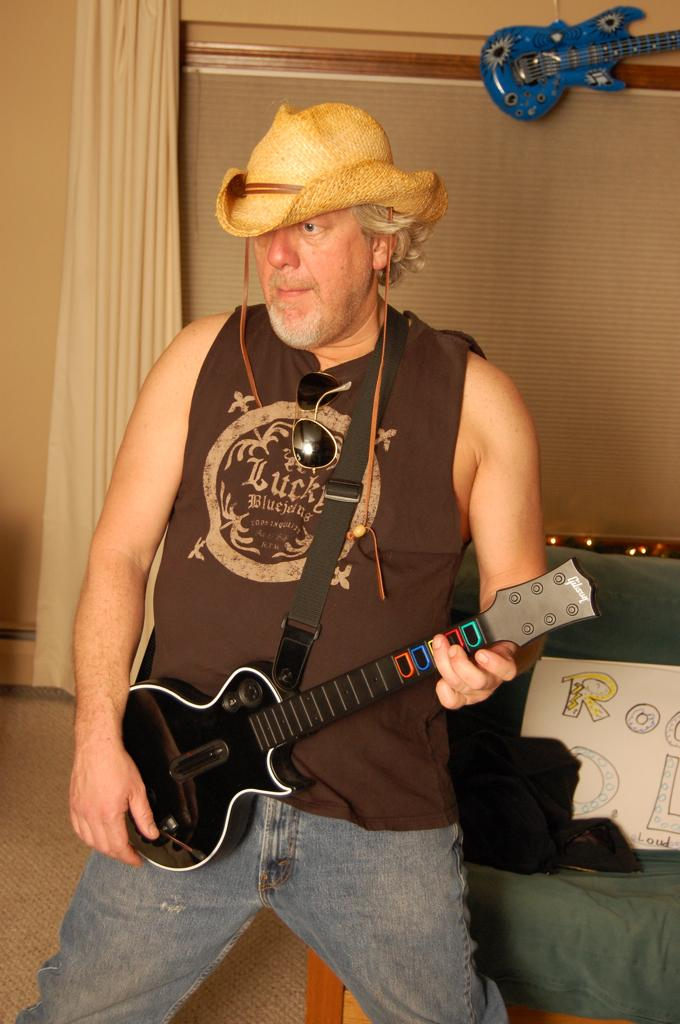What is the main subject of the image? There is a man in the image. What is the man holding in his left hand? The man is holding a guitar with his left hand. Can you describe the man's attire? The man is wearing a cap. What letter is the man regretting not sending in the image? There is no letter or indication of regret present in the image. 